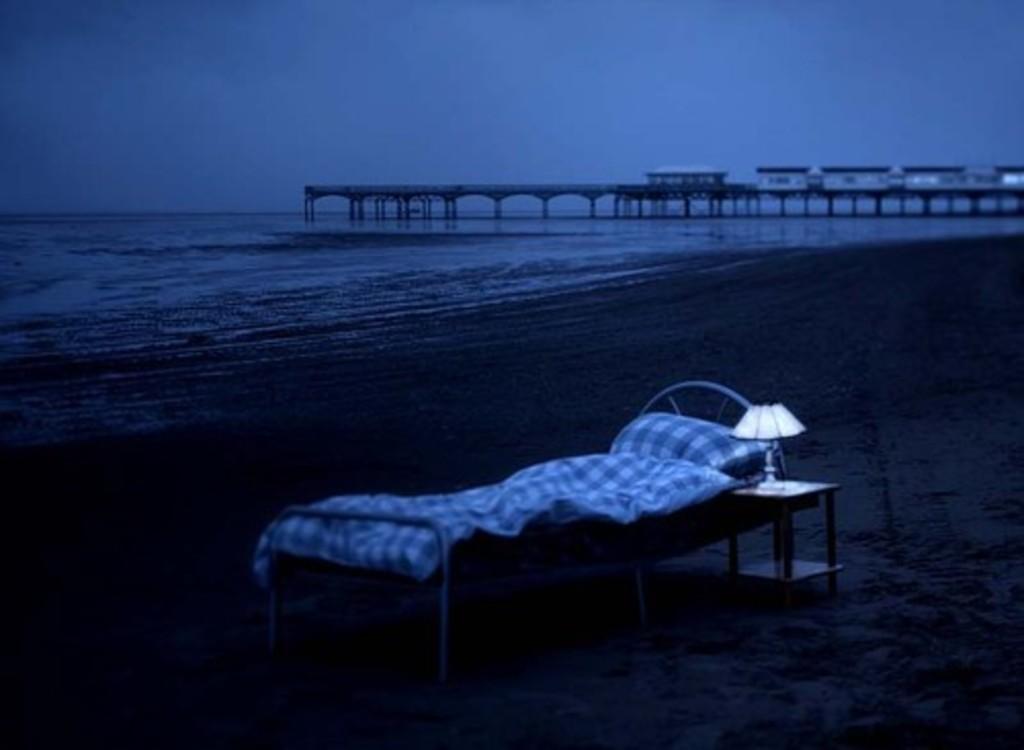Describe this image in one or two sentences. In this image there is water in the background. At the bottom there is sand on which there is a bed. Beside the bed there is a lamp on the table. It seems like an ocean. There is a bridge on the water. At the top there is the sky. This image is taken during the night time. 